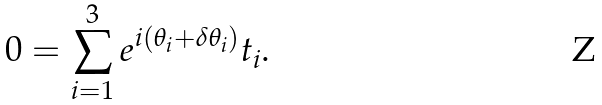Convert formula to latex. <formula><loc_0><loc_0><loc_500><loc_500>0 = \sum _ { i = 1 } ^ { 3 } e ^ { i ( \theta _ { i } + \delta \theta _ { i } ) } t _ { i } .</formula> 